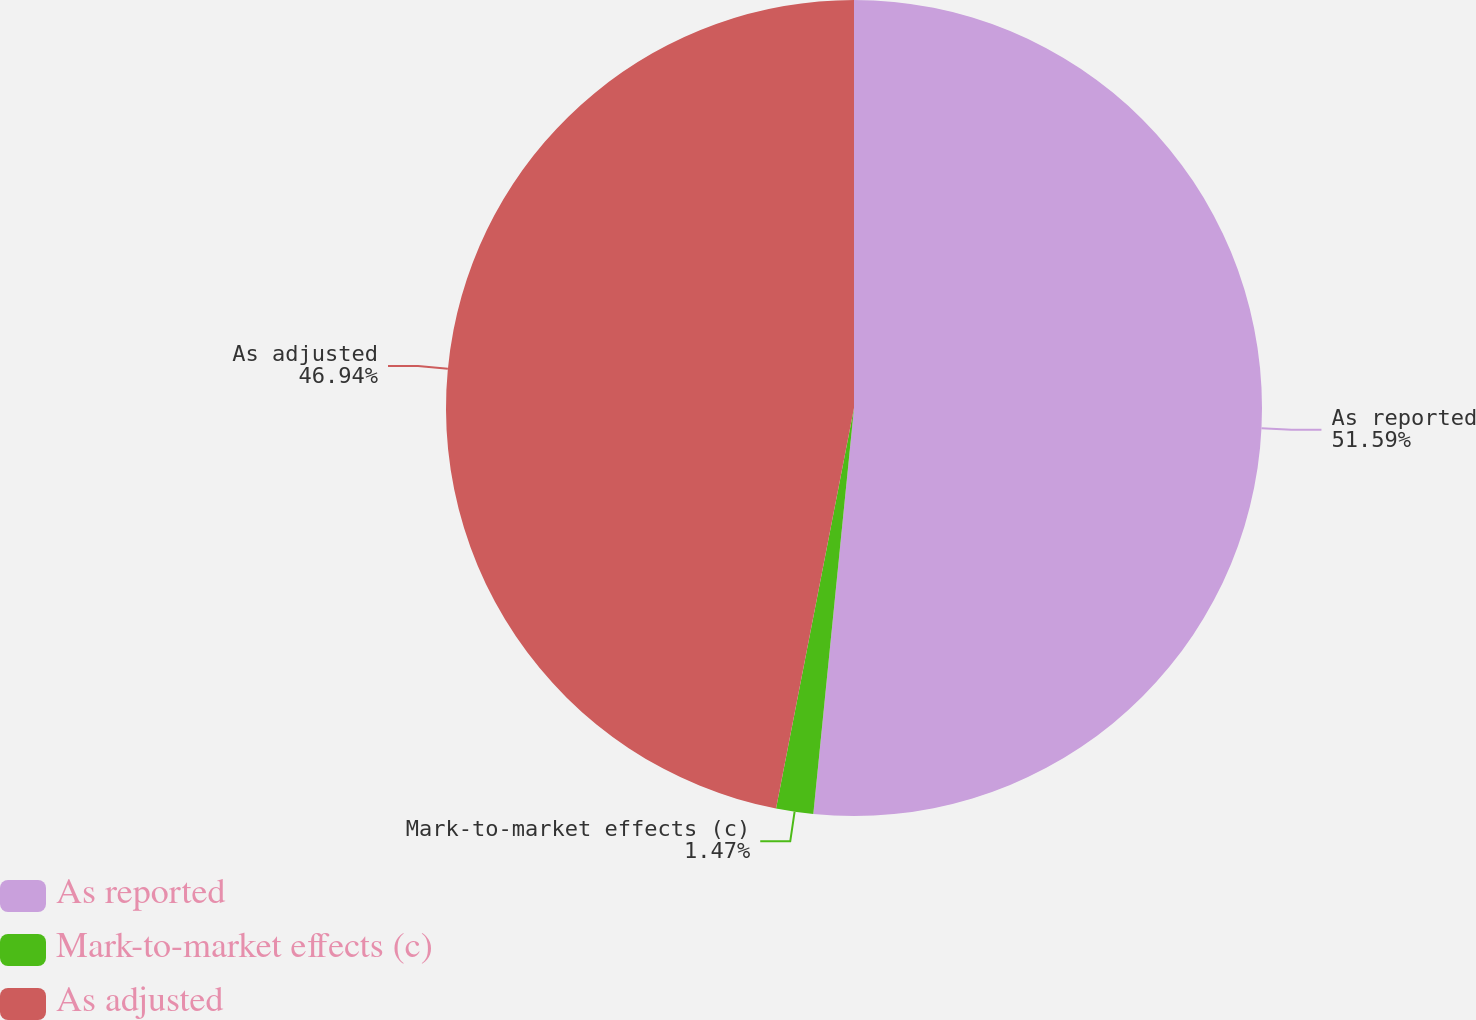<chart> <loc_0><loc_0><loc_500><loc_500><pie_chart><fcel>As reported<fcel>Mark-to-market effects (c)<fcel>As adjusted<nl><fcel>51.59%<fcel>1.47%<fcel>46.94%<nl></chart> 